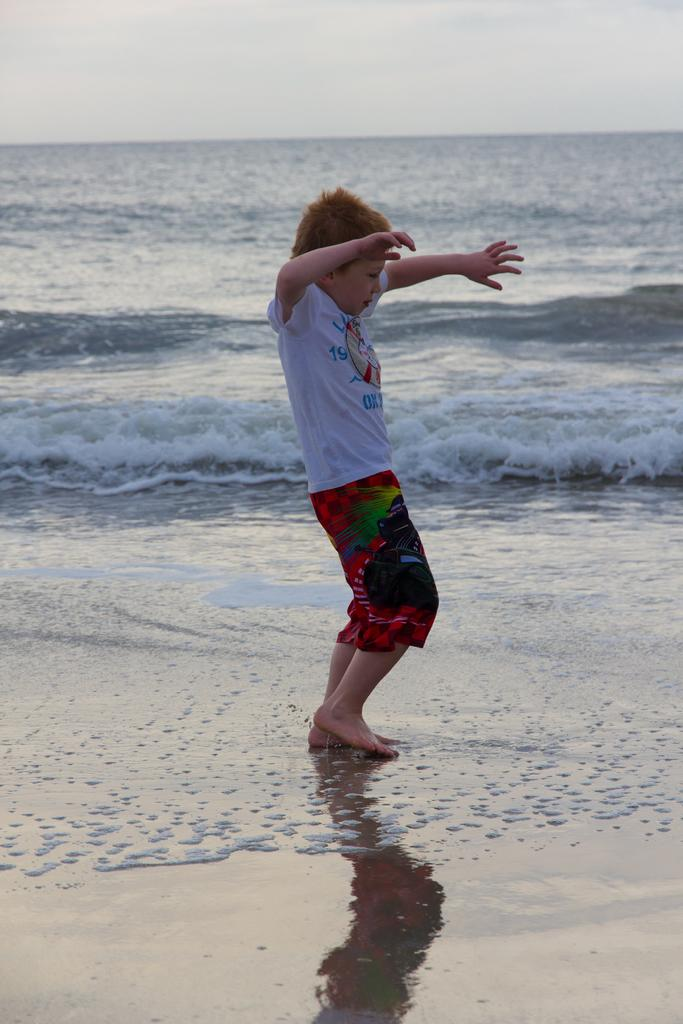What is the main setting of the image? There is the sea in the image. What is the boy near the sea doing? The boy is dancing near the sea. What type of surface is visible near the sea? There is wet sand visible in the image. What is visible at the top of the image? The sky is visible at the top of the image. What type of milk is the boy drinking while dancing in the image? There is no milk present in the image; the boy is dancing near the sea. Can you tell me how many dogs are visible in the image? There are no dogs present in the image. 